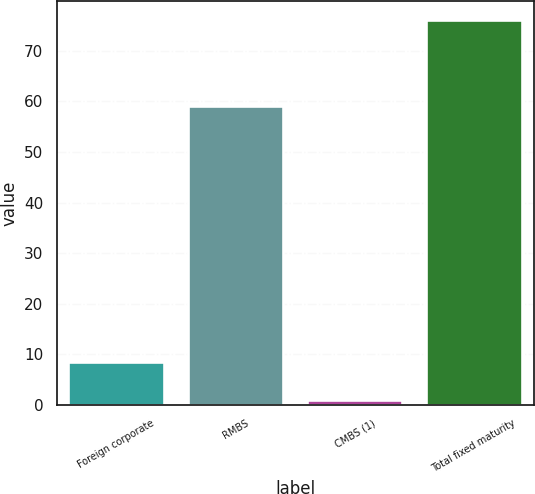<chart> <loc_0><loc_0><loc_500><loc_500><bar_chart><fcel>Foreign corporate<fcel>RMBS<fcel>CMBS (1)<fcel>Total fixed maturity<nl><fcel>8.5<fcel>59<fcel>1<fcel>76<nl></chart> 